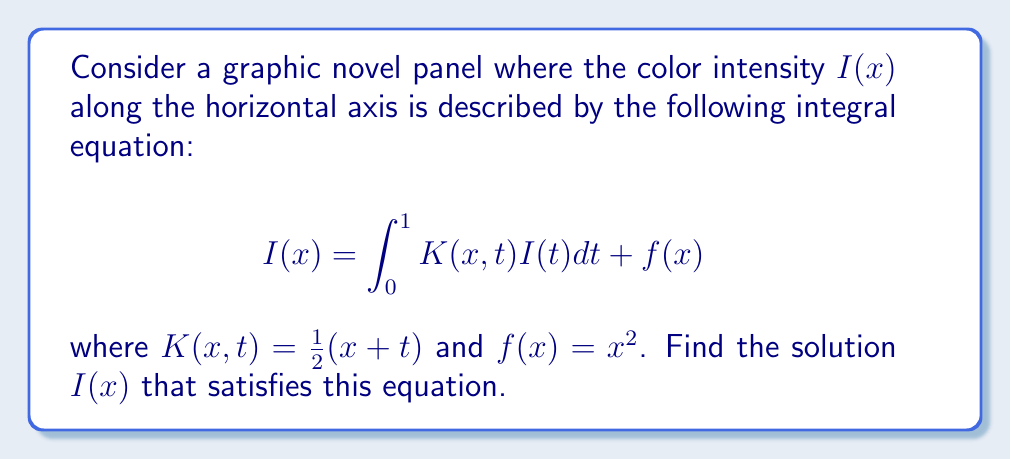Help me with this question. To solve this integral equation, we'll follow these steps:

1) First, we assume that the solution $I(x)$ can be expressed as a polynomial:

   $I(x) = ax^2 + bx + c$

2) Substitute this into the integral equation:

   $ax^2 + bx + c = \int_0^1 \frac{1}{2}(x+t)(at^2 + bt + c)dt + x^2$

3) Evaluate the integral:

   $ax^2 + bx + c = \frac{1}{2}x\int_0^1 (at^2 + bt + c)dt + \frac{1}{2}\int_0^1 t(at^2 + bt + c)dt + x^2$

   $= \frac{1}{2}x(\frac{a}{3} + \frac{b}{2} + c) + \frac{1}{2}(\frac{a}{4} + \frac{b}{3} + \frac{c}{2}) + x^2$

4) Equate coefficients:

   $x^2$ terms: $a = 1$
   $x$ terms: $b = \frac{1}{2}(\frac{a}{3} + \frac{b}{2} + c)$
   constant terms: $c = \frac{1}{2}(\frac{a}{4} + \frac{b}{3} + \frac{c}{2})$

5) Solve this system of equations:

   From the first equation: $a = 1$
   Substituting into the second: $b = \frac{1}{2}(\frac{1}{3} + \frac{b}{2} + c)$
   Substituting into the third: $c = \frac{1}{2}(\frac{1}{4} + \frac{b}{3} + \frac{c}{2})$

   Solving these simultaneously gives: $b = \frac{1}{2}$, $c = \frac{1}{6}$

6) Therefore, the solution is:

   $I(x) = x^2 + \frac{1}{2}x + \frac{1}{6}$
Answer: $I(x) = x^2 + \frac{1}{2}x + \frac{1}{6}$ 